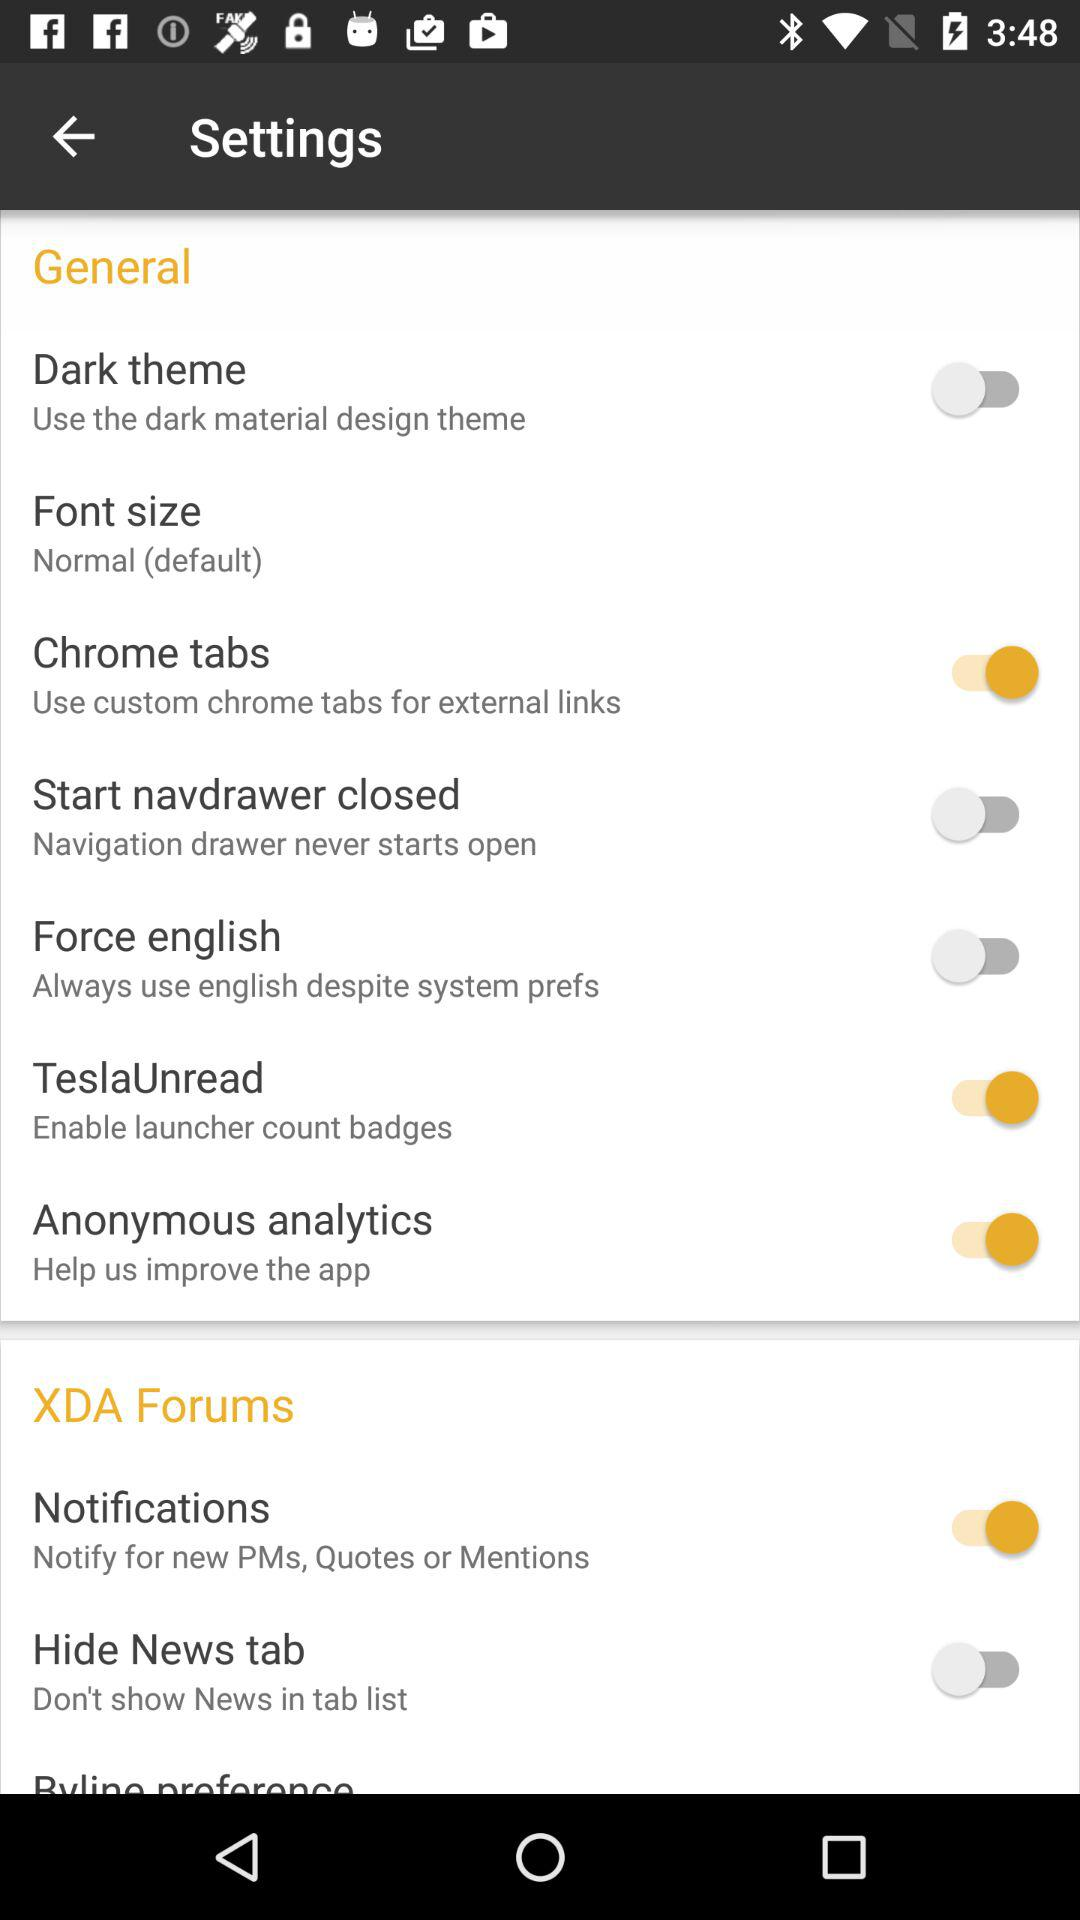Is "Byline preference" on or off?
When the provided information is insufficient, respond with <no answer>. <no answer> 